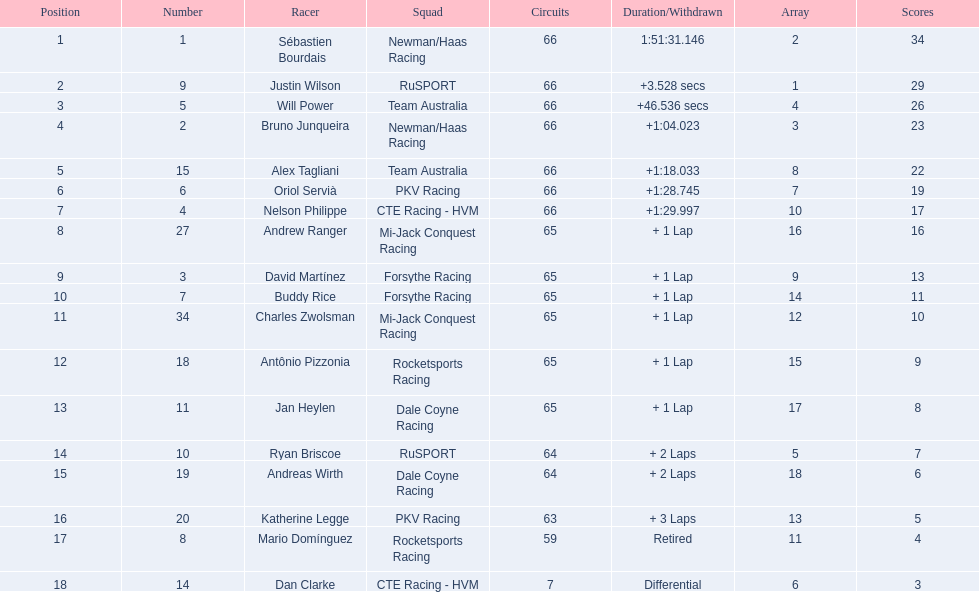What was the highest amount of points scored in the 2006 gran premio? 34. Who scored 34 points? Sébastien Bourdais. 